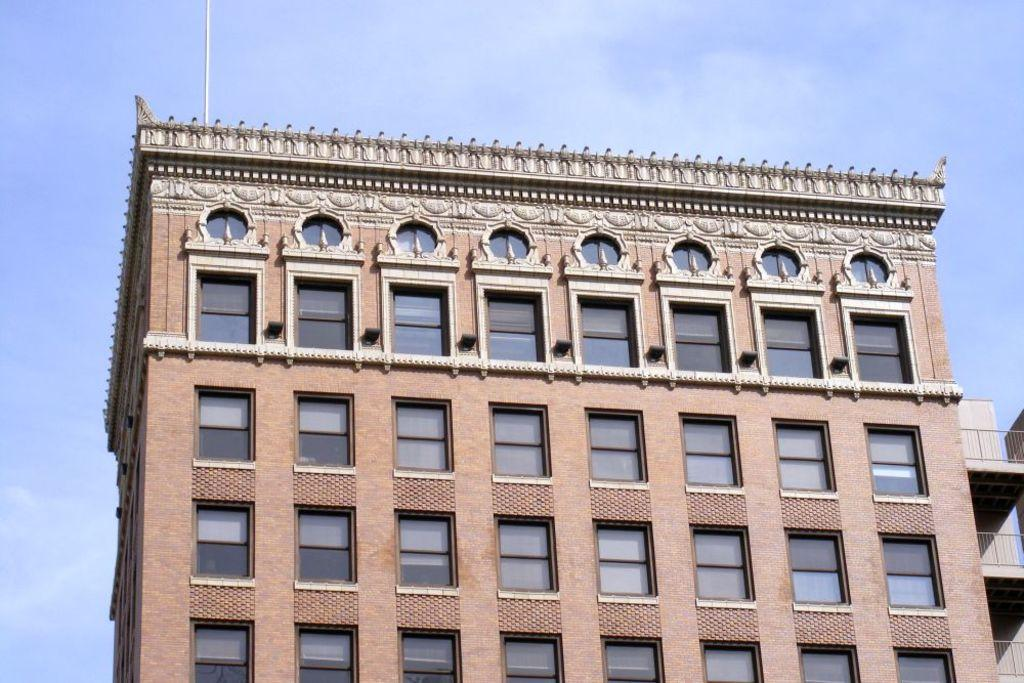What is the main structure in the image? There is a building in the image. What feature can be seen on the building? The building has windows. What is the condition of the sky in the image? The sky is cloudy in the image. How does the building show respect to the scarf in the image? There is no scarf present in the image, and the building does not show respect or any other emotion. 